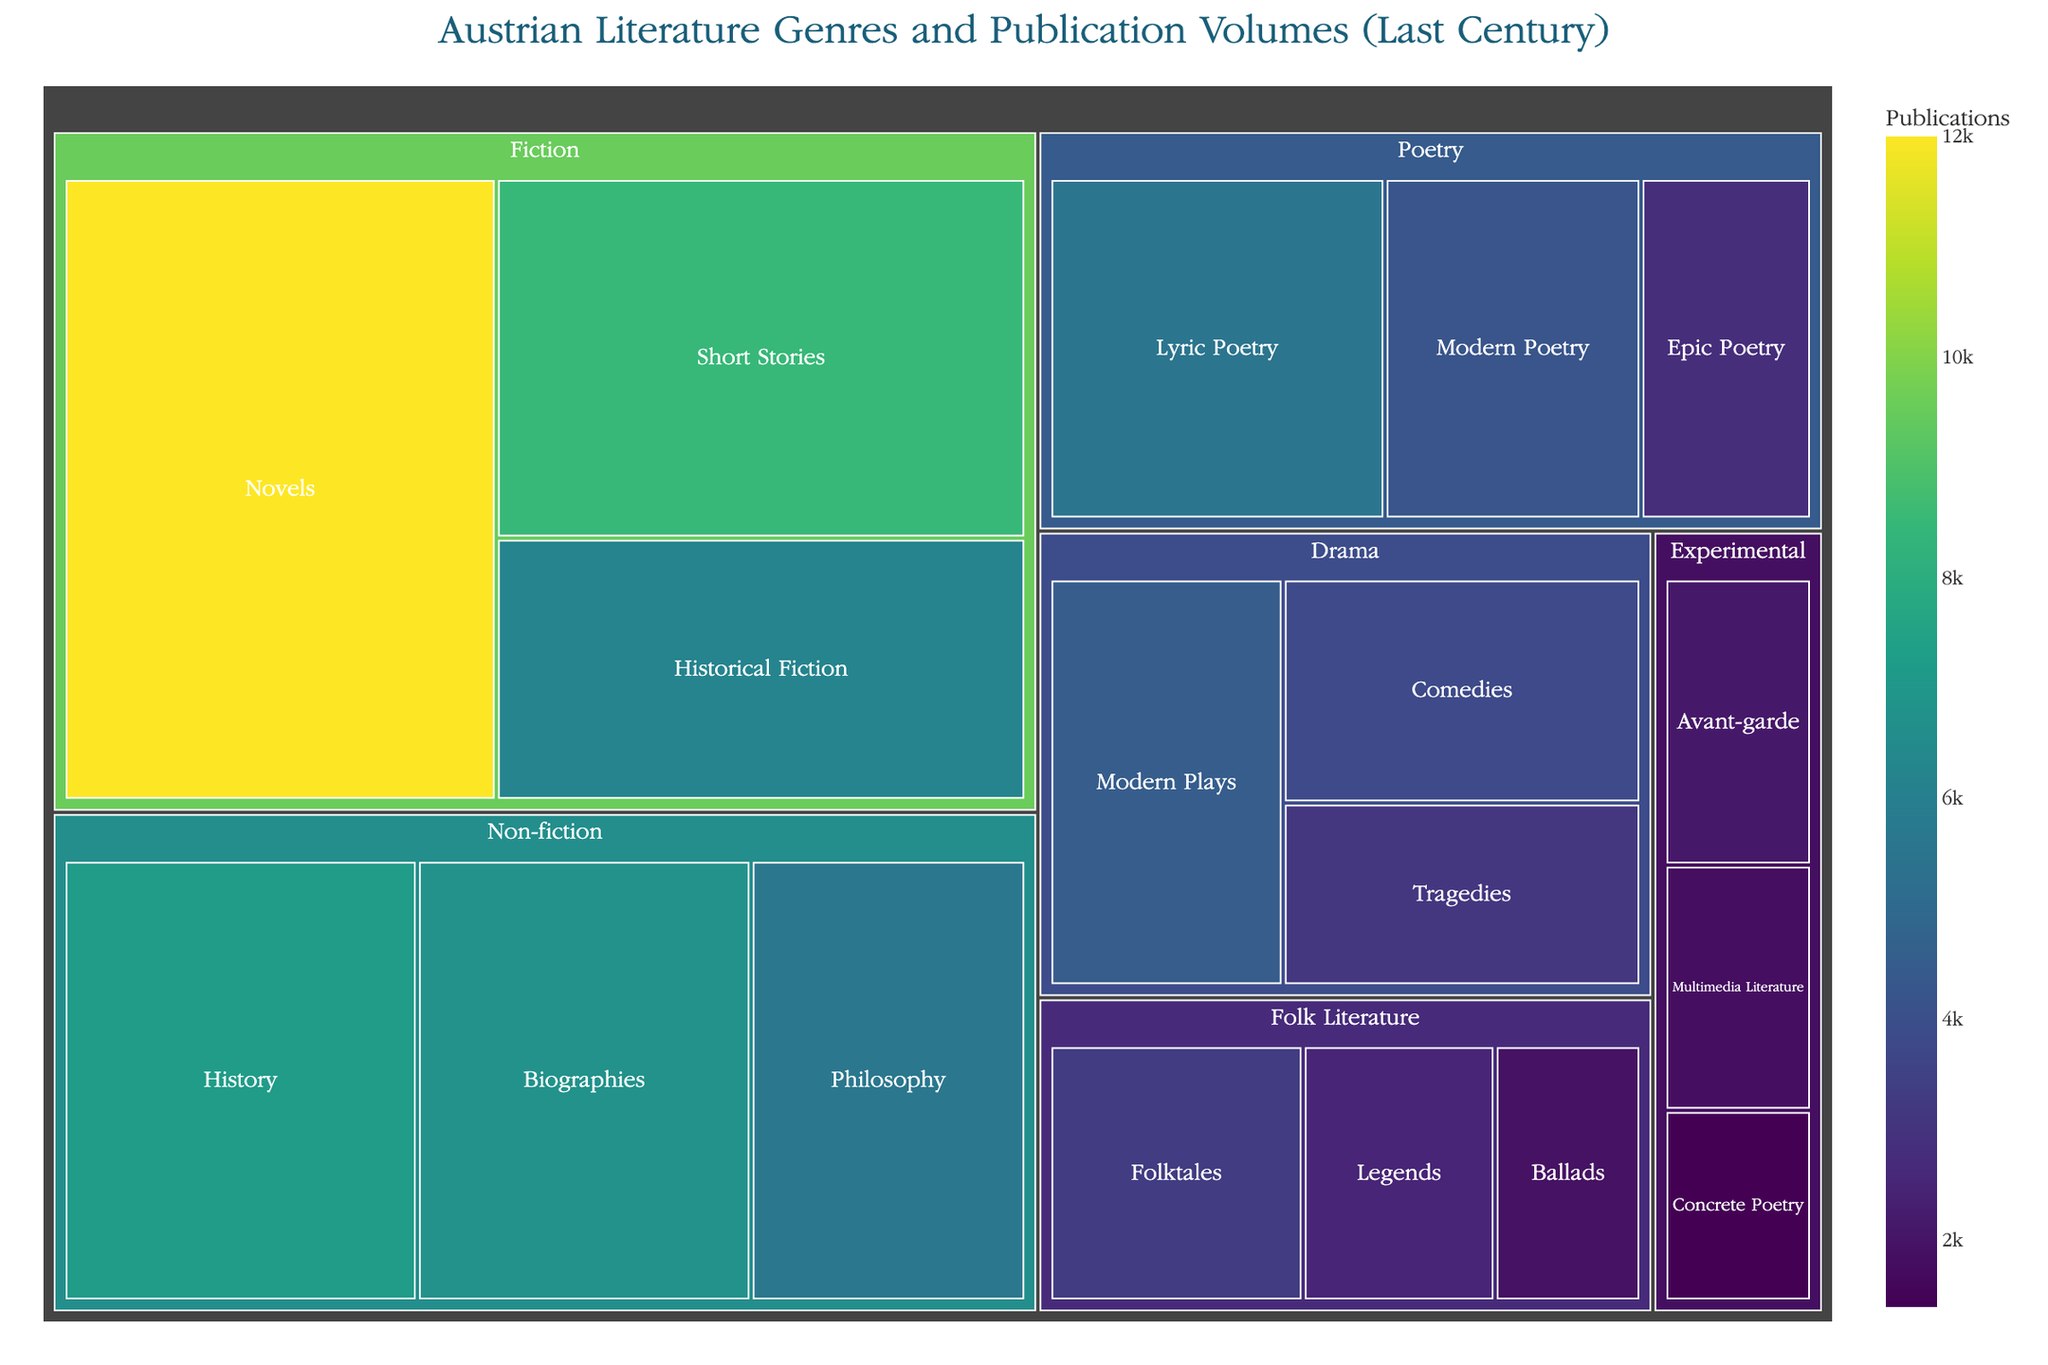What is the total number of publications for the Fiction genre? Summing up all the subgenres under Fiction: Novels (12000) + Short Stories (8500) + Historical Fiction (6200) = 26700
Answer: 26700 Which subgenre has the highest number of publications? By comparing all subgenres, Novels under Fiction have the highest number of publications, totaling 12000
Answer: Novels How many more publications does Historical Fiction have compared to Avant-garde? Subtracting the publications of Avant-garde (2100) from those of Historical Fiction (6200): 6200 - 2100 = 4100
Answer: 4100 What is the average number of publications in the Poetry genre? Summing up all the subgenres under Poetry: Lyric Poetry (5500) + Epic Poetry (2800) + Modern Poetry (4200) = 12500, then divide by 3 (number of subgenres): 12500 / 3 ≈ 4166.67
Answer: 4166.67 Which genre has the least number of publications overall? Summing up the publications for each genre:
- Fiction: 26700
- Poetry: 12500
- Drama: 11400
- Non-fiction: 19600
- Experimental: 5300
- Folk Literature: 7700
Experimental has the least with 5300
Answer: Experimental How does the number of publications in Philosophy compare to Biographies? Philosophy has 5600 publications, and Biographies have 6800 publications; Biographies have more
Answer: Biographies How many subgenres are there in total in the dataset? Counting each subgenre listed in the dataset:
- Fiction: 3
- Poetry: 3
- Drama: 3
- Non-fiction: 3
- Experimental: 3
- Folk Literature: 3
Total is 3 + 3 + 3 + 3 + 3 + 3 = 18
Answer: 18 What is the difference in publication volume between Modern Plays and Tragedies? Tragedies have 3100 publications, and Modern Plays have 4500 publications; the difference is 4500 - 3100 = 1400
Answer: 1400 How do the publications of Lyric Poetry compare to Epic Poetry and Modern Poetry combined? Lyric Poetry has 5500 publications. Summing Epic Poetry (2800) and Modern Poetry (4200): 2800 + 4200 = 7000. Lyric Poetry has fewer publications than the combined total of Epic and Modern Poetry
Answer: Fewer 